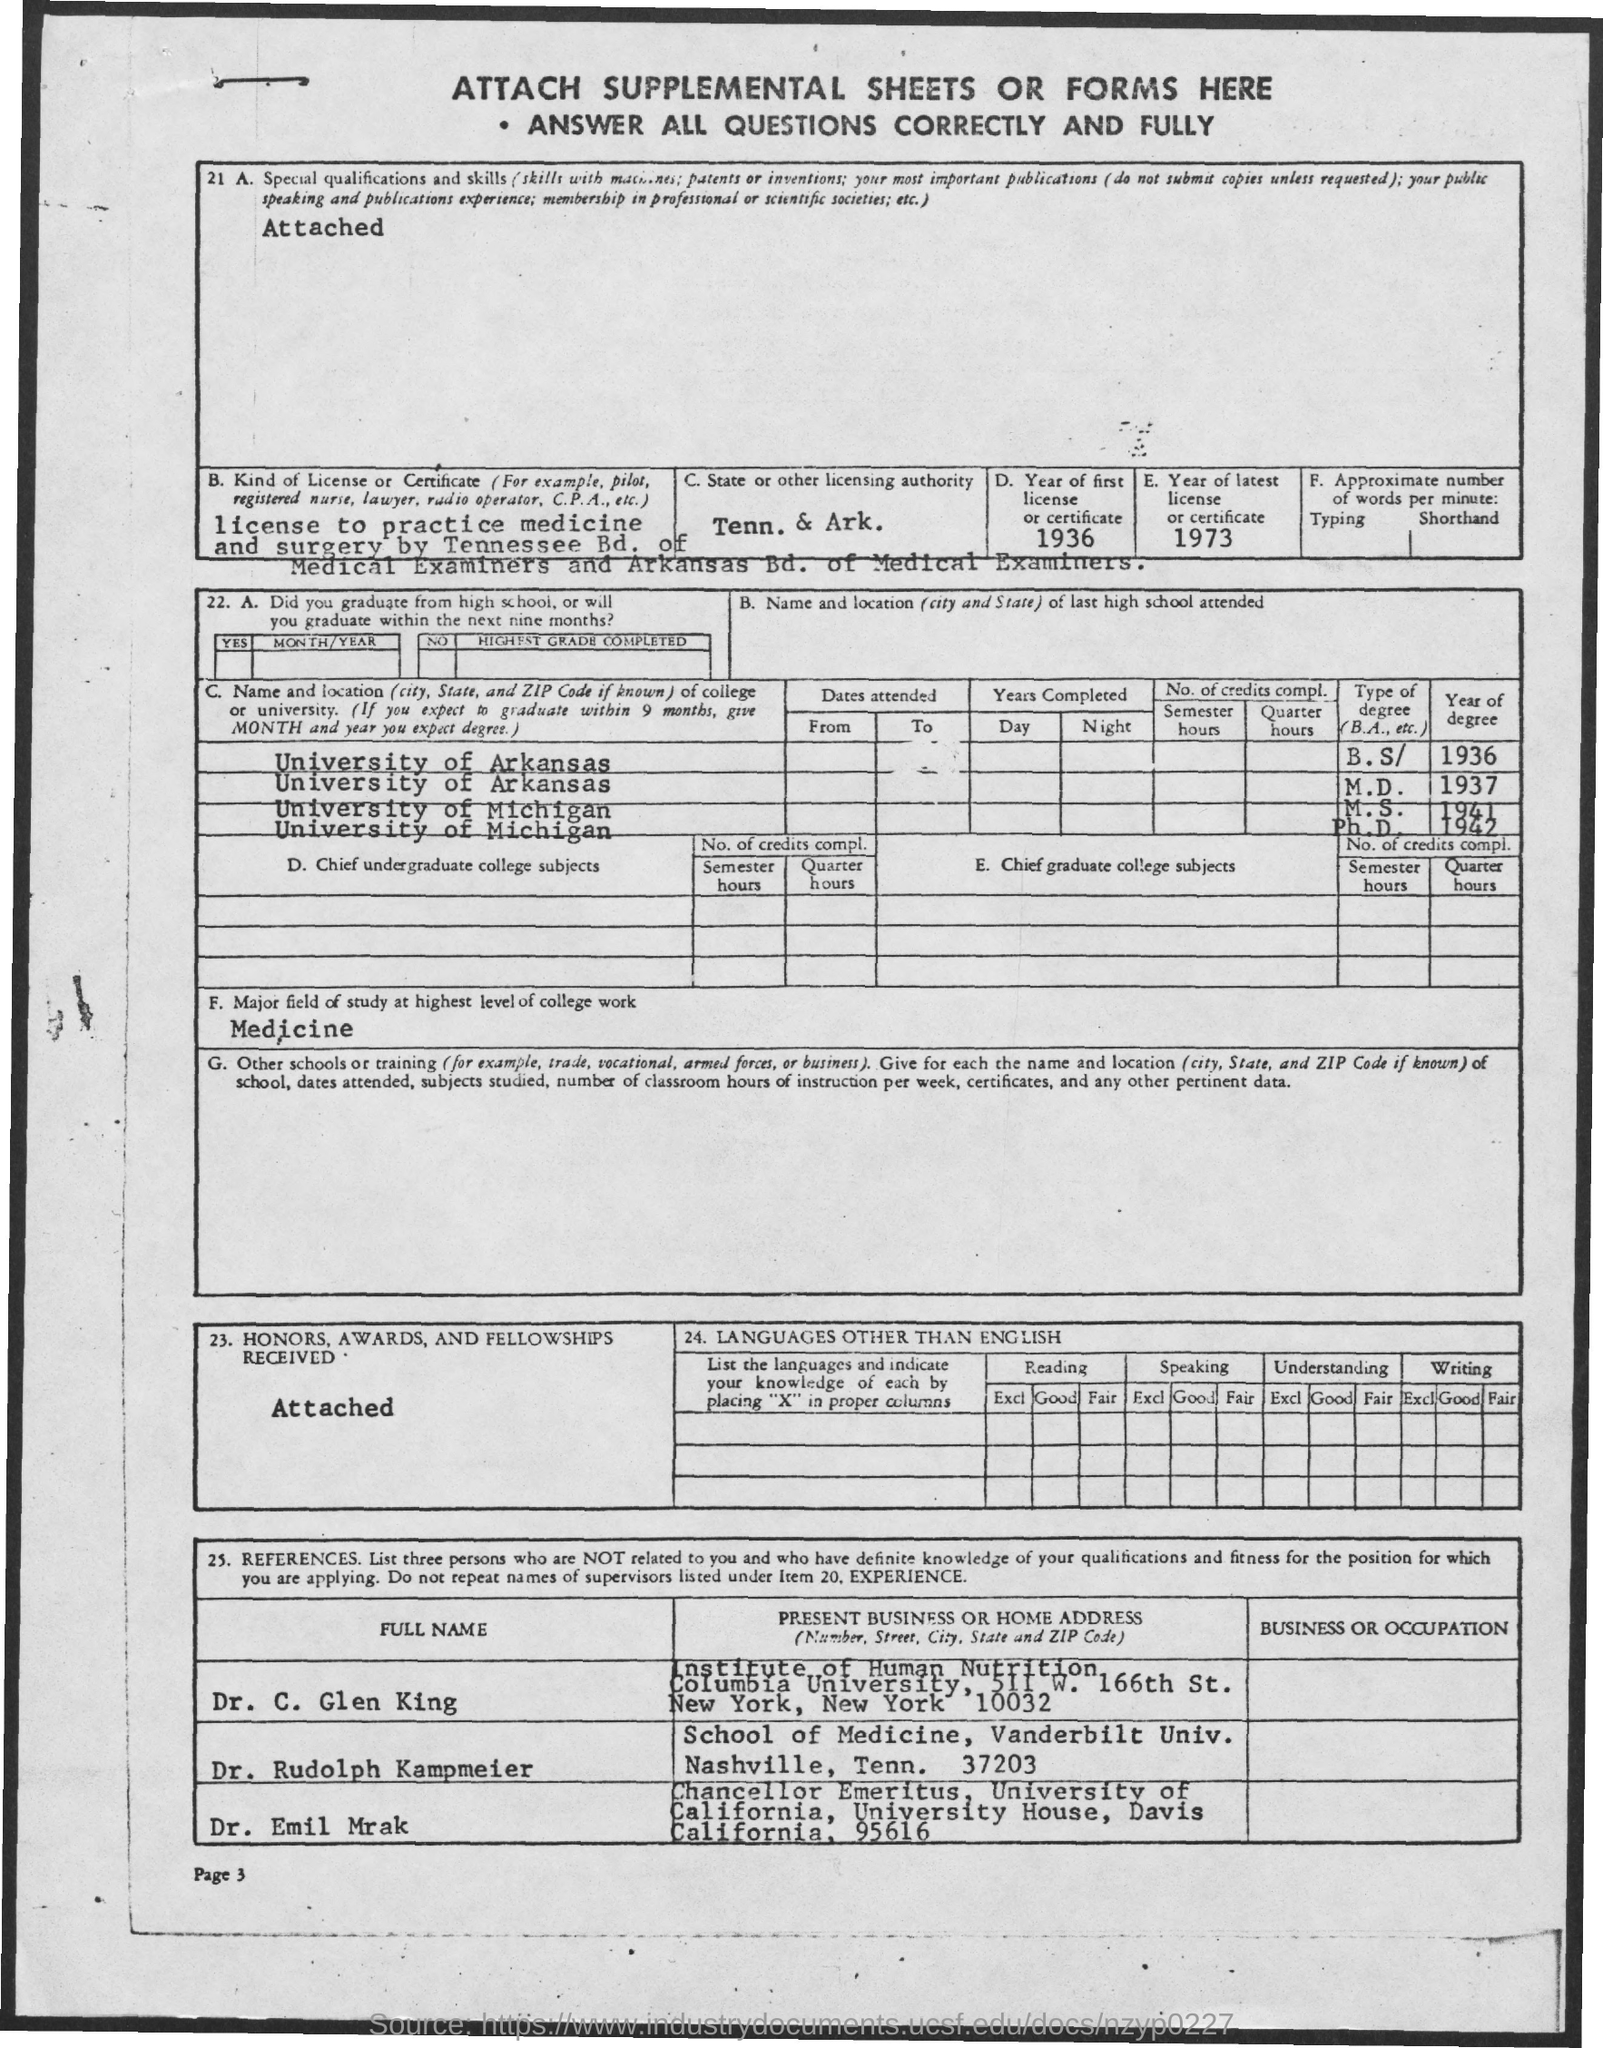What is the C. State or other licencing authority?
Offer a very short reply. Tenn. & Ark. What is the Year of first licence or certificate?
Provide a succinct answer. 1936. What is the Major field of study at highest level of college work?
Your response must be concise. Medicine. 